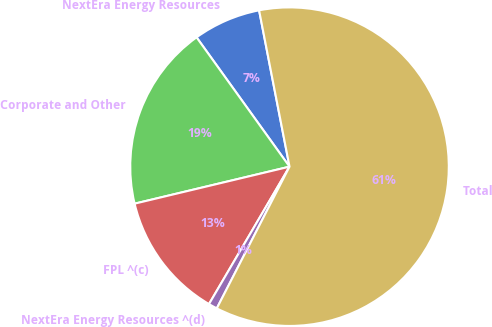<chart> <loc_0><loc_0><loc_500><loc_500><pie_chart><fcel>NextEra Energy Resources<fcel>Corporate and Other<fcel>FPL ^(c)<fcel>NextEra Energy Resources ^(d)<fcel>Total<nl><fcel>6.86%<fcel>18.81%<fcel>12.83%<fcel>0.89%<fcel>60.6%<nl></chart> 